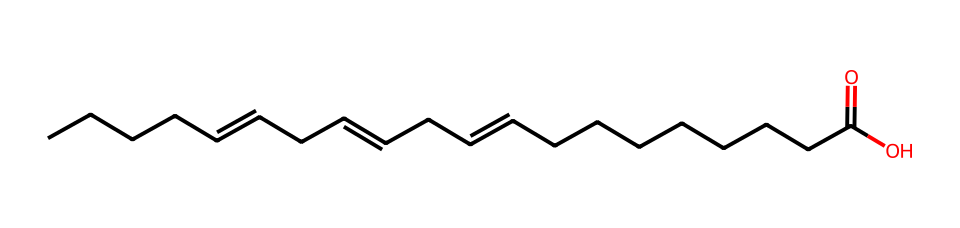What is the total number of carbon atoms in this omega-3 fatty acid? The SMILES representation indicates a long carbon chain. Each "C" corresponds to a carbon atom, and the total can be counted: there are 18 "C" characters present in the structure.
Answer: 18 How many double bonds are present in this fatty acid? The presence of "=" in the SMILES indicates double bonds. By counting the "=" symbols, we can determine that there are three double bonds in the structure.
Answer: 3 What is the functional group present at the end of this fatty acid? The "C(=O)O" segment in the SMILES denotes a carboxylic acid functional group, characterized by a carbon atom double-bonded to an oxygen atom and single-bonded to a hydroxyl (–OH) group.
Answer: carboxylic acid What is the saturation level of this fatty acid? The presence of double bonds indicates that this fatty acid is unsaturated. Since there are three double bonds, it is classified as a polyunsaturated fatty acid.
Answer: polyunsaturated What type of fatty acid is represented by this structure? The presence of multiple double bonds and the specific configuration makes this fatty acid an omega-3 fatty acid. The structure indicates that the first double bond starts at the third carbon from the methyl end.
Answer: omega-3 Which end of the carbon chain is the methyl end? The methyl end is located at the terminal end of the carbon chain, opposite the carboxylic acid group. In general notation, the methyl end is the CH3 group.
Answer: CH3 